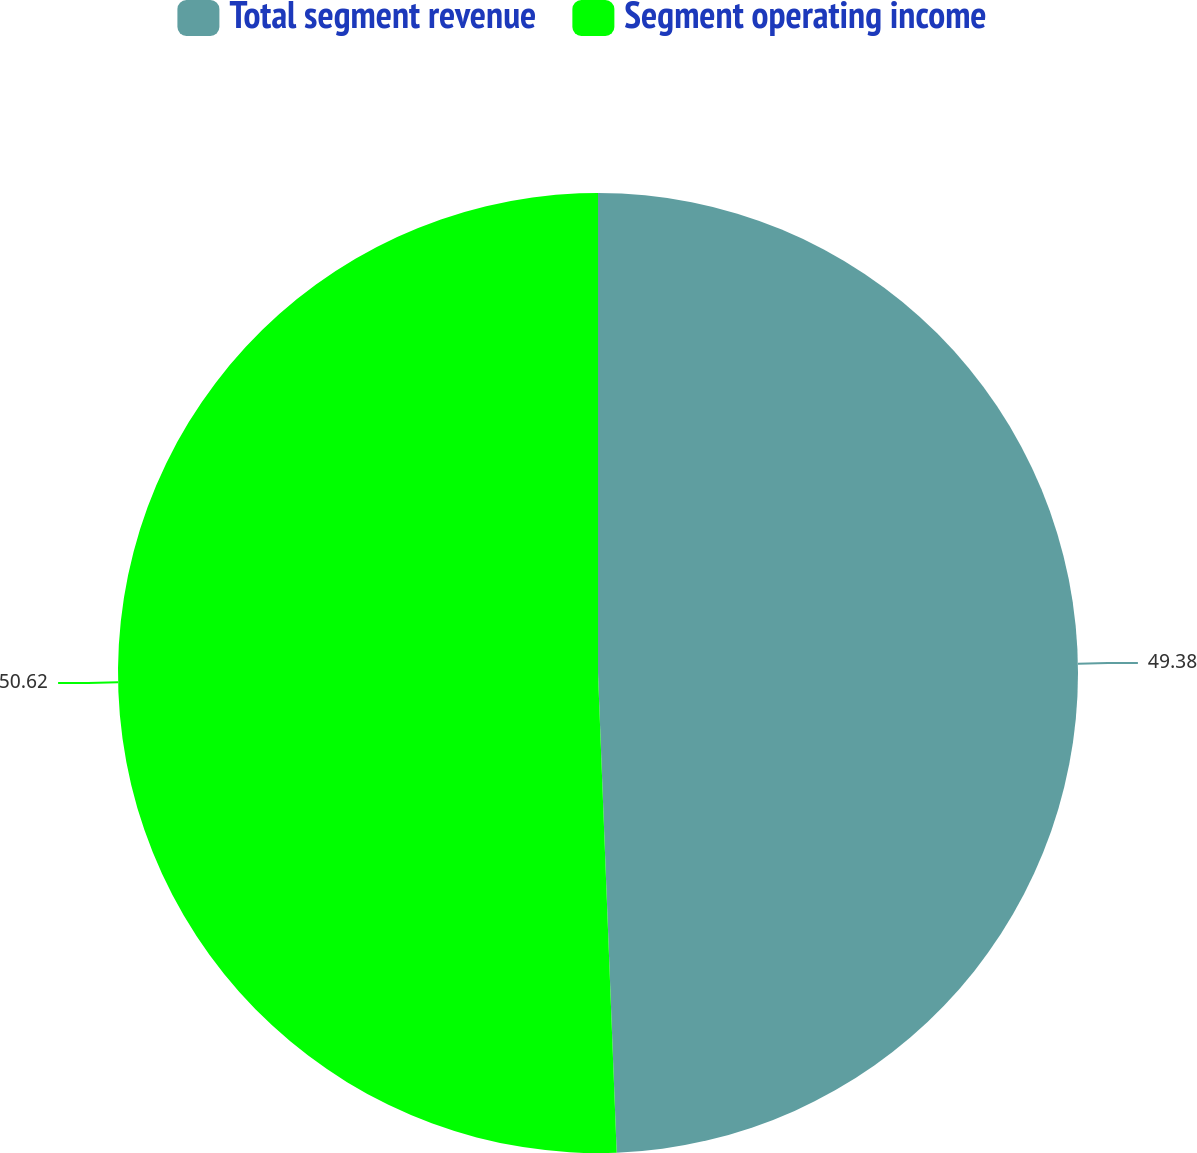Convert chart to OTSL. <chart><loc_0><loc_0><loc_500><loc_500><pie_chart><fcel>Total segment revenue<fcel>Segment operating income<nl><fcel>49.38%<fcel>50.62%<nl></chart> 